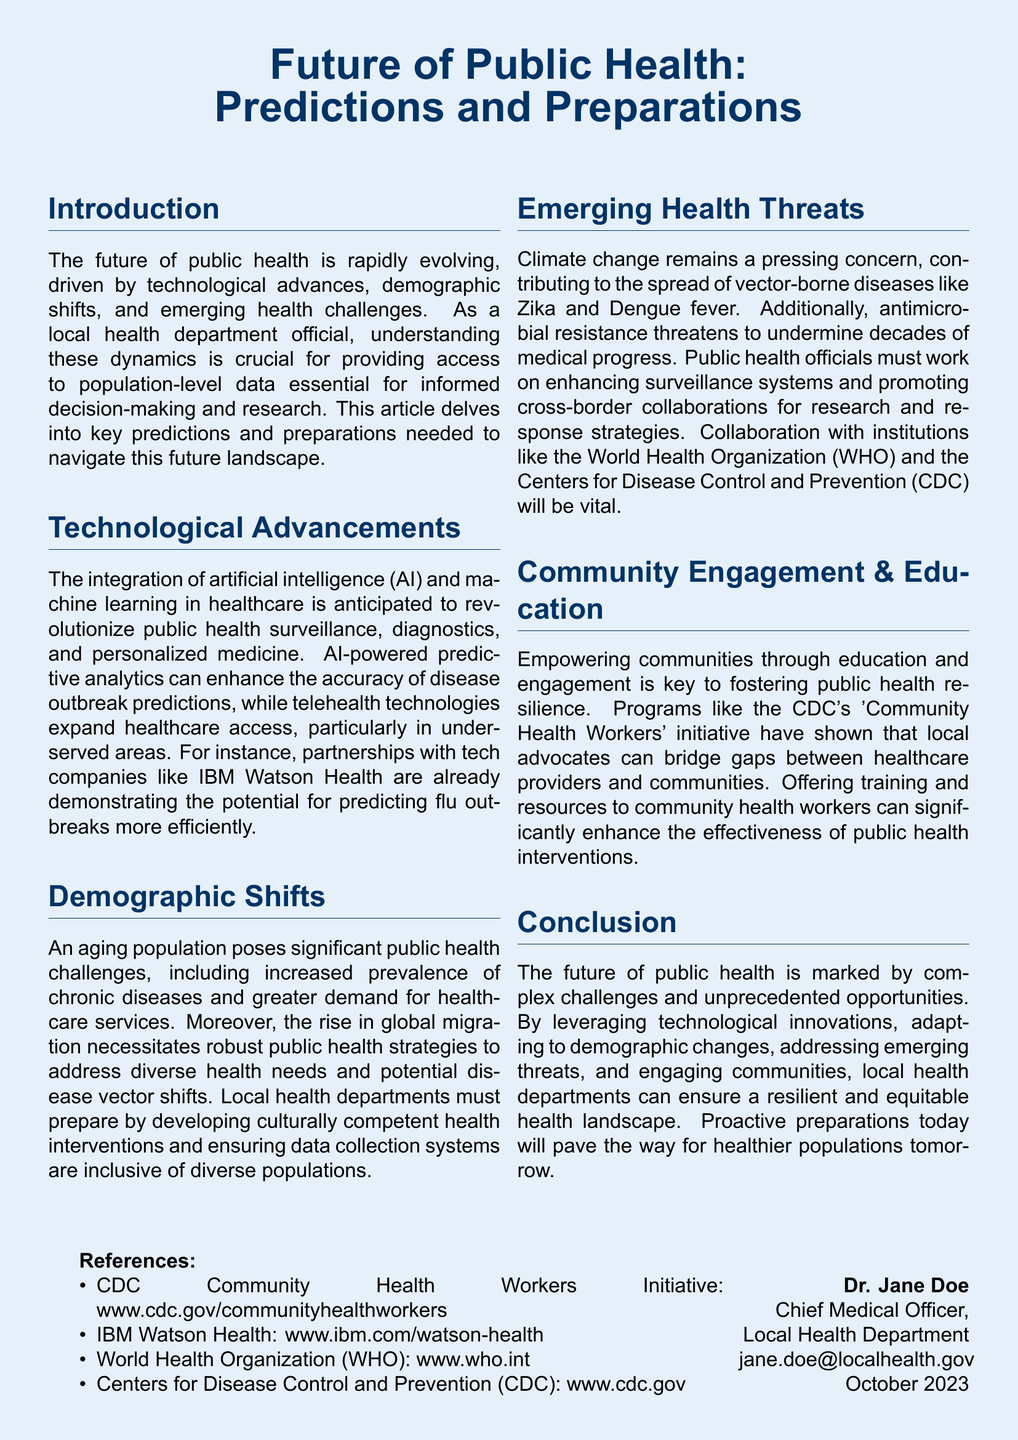What is the title of the article? The title of the article is prominently displayed at the top of the document.
Answer: Future of Public Health: Predictions and Preparations Who is the Chief Medical Officer mentioned in the document? The document lists the Chief Medical Officer's name at the bottom.
Answer: Dr. Jane Doe What key technological advancement is anticipated to revolutionize public health? The document discusses the integration of a specific technology in public health surveillance.
Answer: Artificial intelligence What health initiative does the CDC implement to empower communities? The document mentions a specific initiative focused on community-driven health engagement.
Answer: Community Health Workers What are the two emerging health threats highlighted in the article? The document lists both threats in the section discussing emerging health issues.
Answer: Climate change and antimicrobial resistance What color is used for the document's background? The document specifies the background color used for the entire layout.
Answer: Light blue What organization is mentioned alongside the WHO for public health collaboration? The document includes references to a specific public health institution for collaboration.
Answer: Centers for Disease Control and Prevention How many sections does the article contain? The document outlines multiple distinct sections, each covering different themes.
Answer: Six 